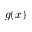Convert formula to latex. <formula><loc_0><loc_0><loc_500><loc_500>g ( x )</formula> 